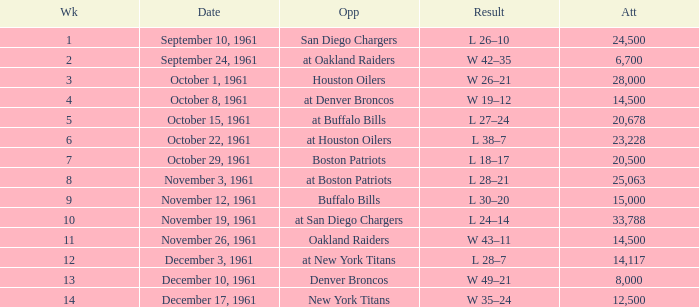What is the top attendance for weeks past 2 on october 29, 1961? 20500.0. I'm looking to parse the entire table for insights. Could you assist me with that? {'header': ['Wk', 'Date', 'Opp', 'Result', 'Att'], 'rows': [['1', 'September 10, 1961', 'San Diego Chargers', 'L 26–10', '24,500'], ['2', 'September 24, 1961', 'at Oakland Raiders', 'W 42–35', '6,700'], ['3', 'October 1, 1961', 'Houston Oilers', 'W 26–21', '28,000'], ['4', 'October 8, 1961', 'at Denver Broncos', 'W 19–12', '14,500'], ['5', 'October 15, 1961', 'at Buffalo Bills', 'L 27–24', '20,678'], ['6', 'October 22, 1961', 'at Houston Oilers', 'L 38–7', '23,228'], ['7', 'October 29, 1961', 'Boston Patriots', 'L 18–17', '20,500'], ['8', 'November 3, 1961', 'at Boston Patriots', 'L 28–21', '25,063'], ['9', 'November 12, 1961', 'Buffalo Bills', 'L 30–20', '15,000'], ['10', 'November 19, 1961', 'at San Diego Chargers', 'L 24–14', '33,788'], ['11', 'November 26, 1961', 'Oakland Raiders', 'W 43–11', '14,500'], ['12', 'December 3, 1961', 'at New York Titans', 'L 28–7', '14,117'], ['13', 'December 10, 1961', 'Denver Broncos', 'W 49–21', '8,000'], ['14', 'December 17, 1961', 'New York Titans', 'W 35–24', '12,500']]} 